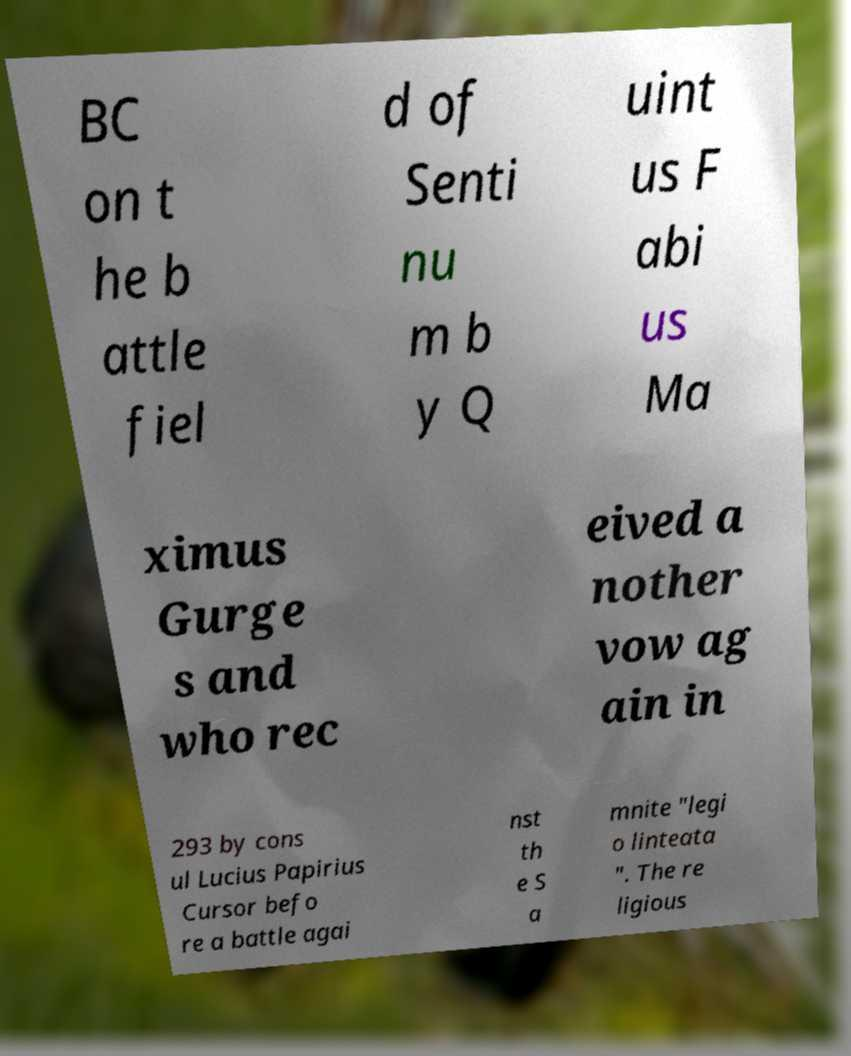For documentation purposes, I need the text within this image transcribed. Could you provide that? BC on t he b attle fiel d of Senti nu m b y Q uint us F abi us Ma ximus Gurge s and who rec eived a nother vow ag ain in 293 by cons ul Lucius Papirius Cursor befo re a battle agai nst th e S a mnite "legi o linteata ". The re ligious 